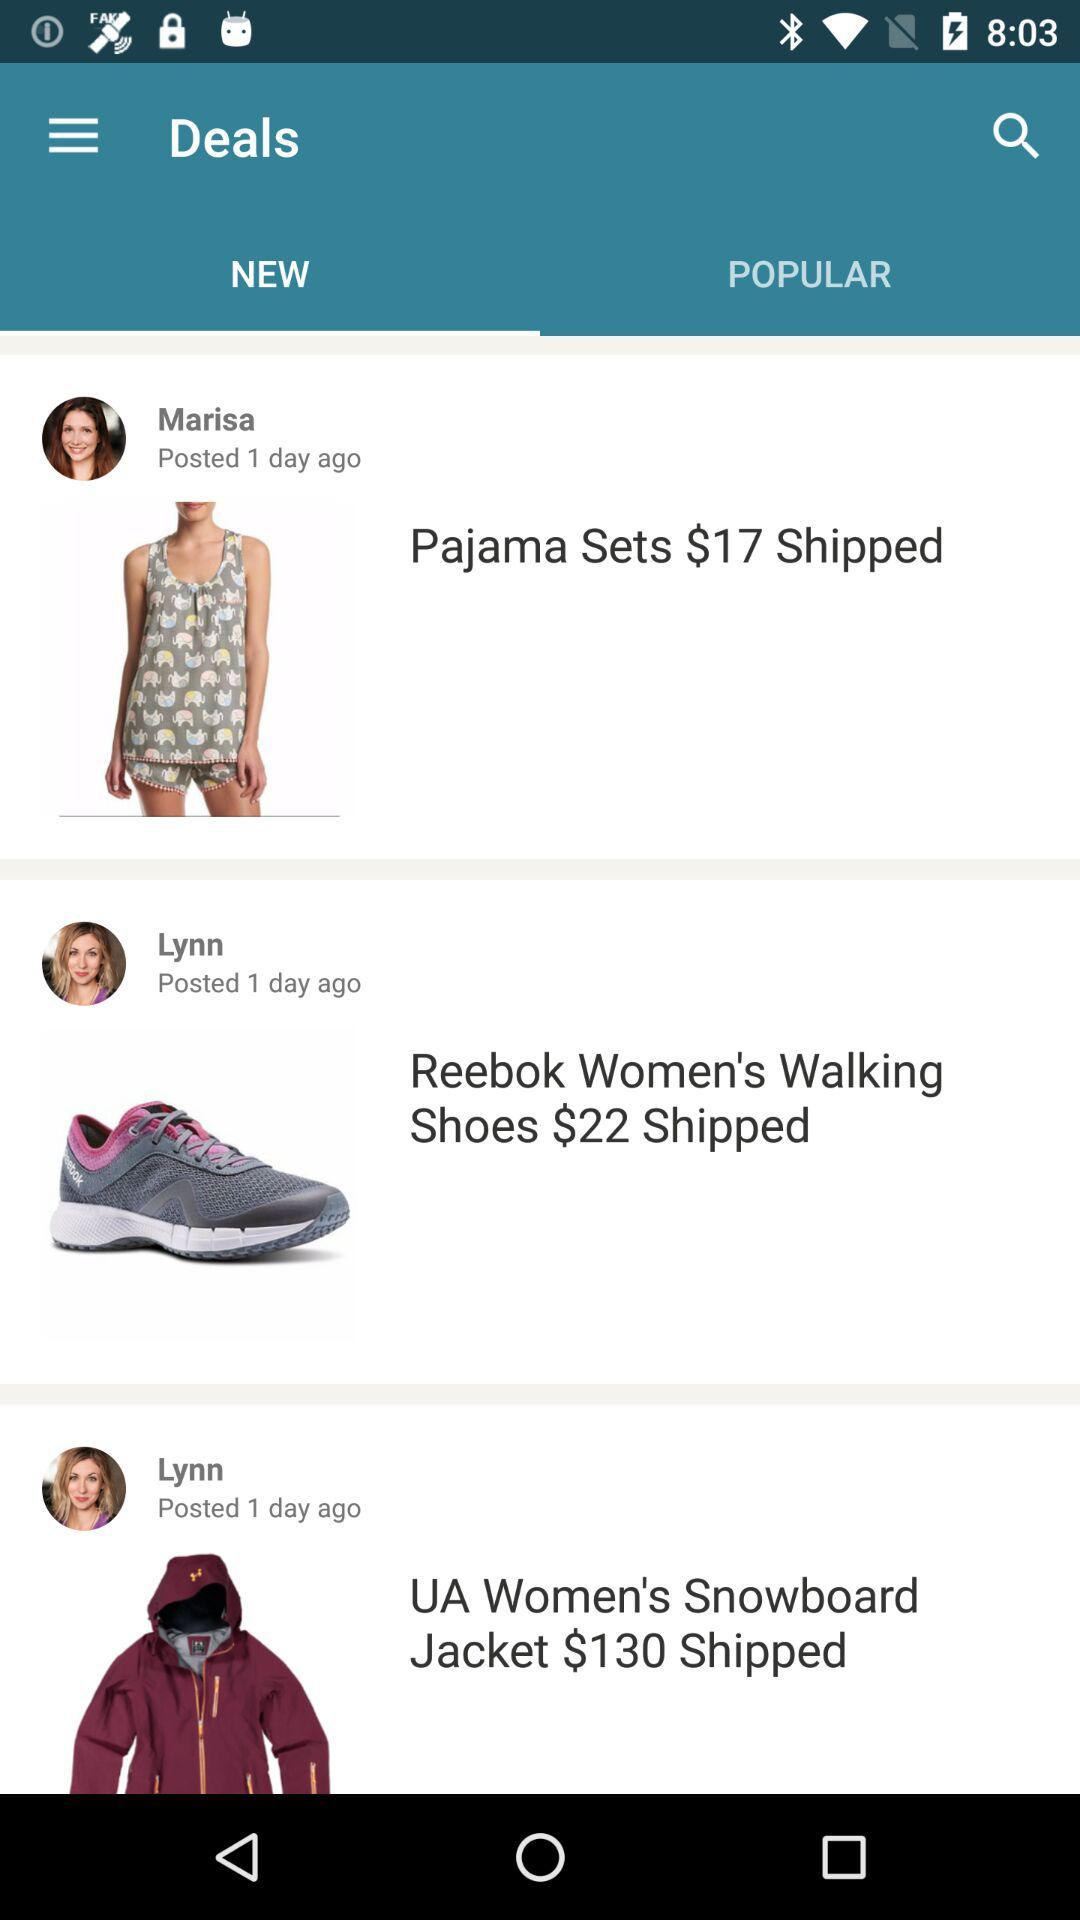Which new item has been posted by Lynn, whose price is $130? The new item that has been posted by Lynn is "UA Women's Snowboard Jacket". 